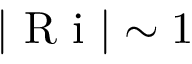Convert formula to latex. <formula><loc_0><loc_0><loc_500><loc_500>| R i | \sim 1</formula> 